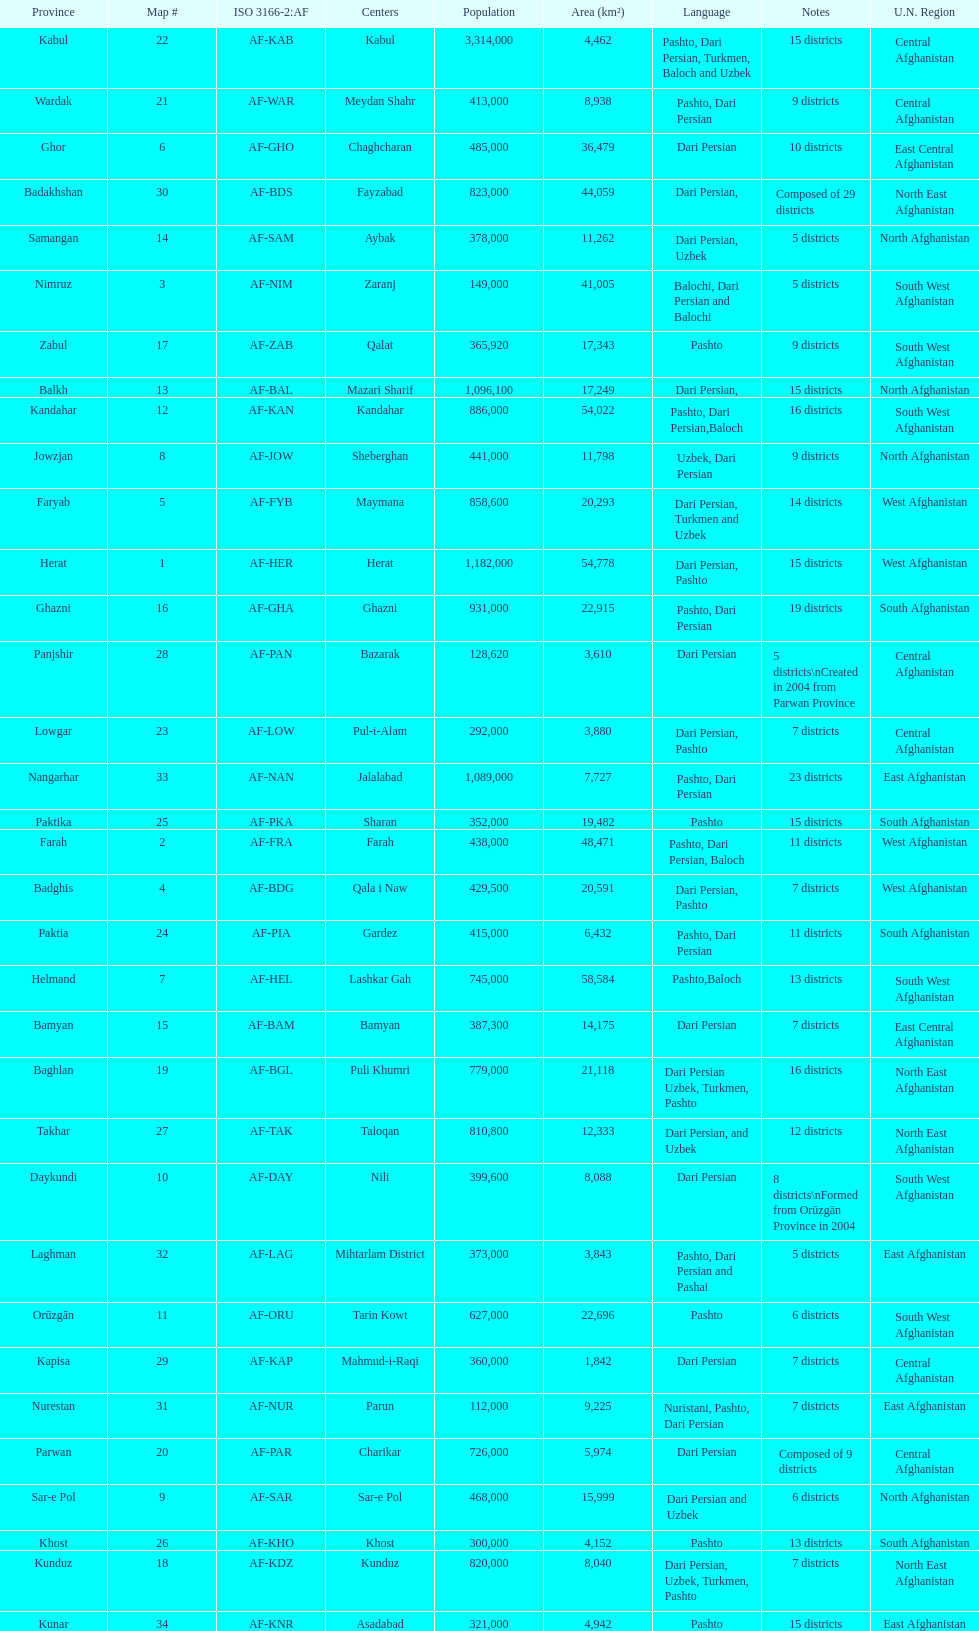I'm looking to parse the entire table for insights. Could you assist me with that? {'header': ['Province', 'Map #', 'ISO 3166-2:AF', 'Centers', 'Population', 'Area (km²)', 'Language', 'Notes', 'U.N. Region'], 'rows': [['Kabul', '22', 'AF-KAB', 'Kabul', '3,314,000', '4,462', 'Pashto, Dari Persian, Turkmen, Baloch and Uzbek', '15 districts', 'Central Afghanistan'], ['Wardak', '21', 'AF-WAR', 'Meydan Shahr', '413,000', '8,938', 'Pashto, Dari Persian', '9 districts', 'Central Afghanistan'], ['Ghor', '6', 'AF-GHO', 'Chaghcharan', '485,000', '36,479', 'Dari Persian', '10 districts', 'East Central Afghanistan'], ['Badakhshan', '30', 'AF-BDS', 'Fayzabad', '823,000', '44,059', 'Dari Persian,', 'Composed of 29 districts', 'North East Afghanistan'], ['Samangan', '14', 'AF-SAM', 'Aybak', '378,000', '11,262', 'Dari Persian, Uzbek', '5 districts', 'North Afghanistan'], ['Nimruz', '3', 'AF-NIM', 'Zaranj', '149,000', '41,005', 'Balochi, Dari Persian and Balochi', '5 districts', 'South West Afghanistan'], ['Zabul', '17', 'AF-ZAB', 'Qalat', '365,920', '17,343', 'Pashto', '9 districts', 'South West Afghanistan'], ['Balkh', '13', 'AF-BAL', 'Mazari Sharif', '1,096,100', '17,249', 'Dari Persian,', '15 districts', 'North Afghanistan'], ['Kandahar', '12', 'AF-KAN', 'Kandahar', '886,000', '54,022', 'Pashto, Dari Persian,Baloch', '16 districts', 'South West Afghanistan'], ['Jowzjan', '8', 'AF-JOW', 'Sheberghan', '441,000', '11,798', 'Uzbek, Dari Persian', '9 districts', 'North Afghanistan'], ['Faryab', '5', 'AF-FYB', 'Maymana', '858,600', '20,293', 'Dari Persian, Turkmen and Uzbek', '14 districts', 'West Afghanistan'], ['Herat', '1', 'AF-HER', 'Herat', '1,182,000', '54,778', 'Dari Persian, Pashto', '15 districts', 'West Afghanistan'], ['Ghazni', '16', 'AF-GHA', 'Ghazni', '931,000', '22,915', 'Pashto, Dari Persian', '19 districts', 'South Afghanistan'], ['Panjshir', '28', 'AF-PAN', 'Bazarak', '128,620', '3,610', 'Dari Persian', '5 districts\\nCreated in 2004 from Parwan Province', 'Central Afghanistan'], ['Lowgar', '23', 'AF-LOW', 'Pul-i-Alam', '292,000', '3,880', 'Dari Persian, Pashto', '7 districts', 'Central Afghanistan'], ['Nangarhar', '33', 'AF-NAN', 'Jalalabad', '1,089,000', '7,727', 'Pashto, Dari Persian', '23 districts', 'East Afghanistan'], ['Paktika', '25', 'AF-PKA', 'Sharan', '352,000', '19,482', 'Pashto', '15 districts', 'South Afghanistan'], ['Farah', '2', 'AF-FRA', 'Farah', '438,000', '48,471', 'Pashto, Dari Persian, Baloch', '11 districts', 'West Afghanistan'], ['Badghis', '4', 'AF-BDG', 'Qala i Naw', '429,500', '20,591', 'Dari Persian, Pashto', '7 districts', 'West Afghanistan'], ['Paktia', '24', 'AF-PIA', 'Gardez', '415,000', '6,432', 'Pashto, Dari Persian', '11 districts', 'South Afghanistan'], ['Helmand', '7', 'AF-HEL', 'Lashkar Gah', '745,000', '58,584', 'Pashto,Baloch', '13 districts', 'South West Afghanistan'], ['Bamyan', '15', 'AF-BAM', 'Bamyan', '387,300', '14,175', 'Dari Persian', '7 districts', 'East Central Afghanistan'], ['Baghlan', '19', 'AF-BGL', 'Puli Khumri', '779,000', '21,118', 'Dari Persian Uzbek, Turkmen, Pashto', '16 districts', 'North East Afghanistan'], ['Takhar', '27', 'AF-TAK', 'Taloqan', '810,800', '12,333', 'Dari Persian, and Uzbek', '12 districts', 'North East Afghanistan'], ['Daykundi', '10', 'AF-DAY', 'Nili', '399,600', '8,088', 'Dari Persian', '8 districts\\nFormed from Orūzgān Province in 2004', 'South West Afghanistan'], ['Laghman', '32', 'AF-LAG', 'Mihtarlam District', '373,000', '3,843', 'Pashto, Dari Persian and Pashai', '5 districts', 'East Afghanistan'], ['Orūzgān', '11', 'AF-ORU', 'Tarin Kowt', '627,000', '22,696', 'Pashto', '6 districts', 'South West Afghanistan'], ['Kapisa', '29', 'AF-KAP', 'Mahmud-i-Raqi', '360,000', '1,842', 'Dari Persian', '7 districts', 'Central Afghanistan'], ['Nurestan', '31', 'AF-NUR', 'Parun', '112,000', '9,225', 'Nuristani, Pashto, Dari Persian', '7 districts', 'East Afghanistan'], ['Parwan', '20', 'AF-PAR', 'Charikar', '726,000', '5,974', 'Dari Persian', 'Composed of 9 districts', 'Central Afghanistan'], ['Sar-e Pol', '9', 'AF-SAR', 'Sar-e Pol', '468,000', '15,999', 'Dari Persian and Uzbek', '6 districts', 'North Afghanistan'], ['Khost', '26', 'AF-KHO', 'Khost', '300,000', '4,152', 'Pashto', '13 districts', 'South Afghanistan'], ['Kunduz', '18', 'AF-KDZ', 'Kunduz', '820,000', '8,040', 'Dari Persian, Uzbek, Turkmen, Pashto', '7 districts', 'North East Afghanistan'], ['Kunar', '34', 'AF-KNR', 'Asadabad', '321,000', '4,942', 'Pashto', '15 districts', 'East Afghanistan']]} What province in afghanistanhas the greatest population? Kabul. 